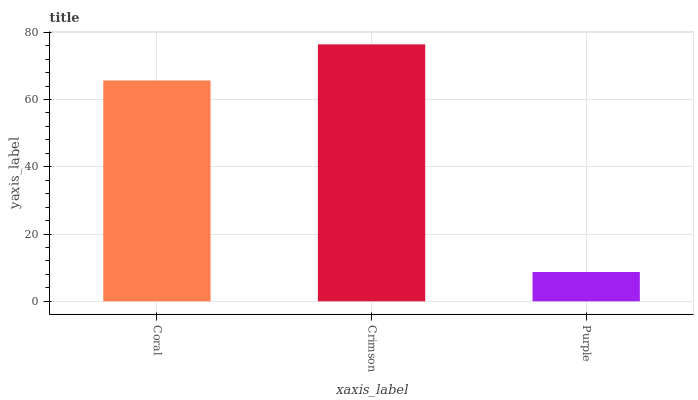Is Crimson the minimum?
Answer yes or no. No. Is Purple the maximum?
Answer yes or no. No. Is Crimson greater than Purple?
Answer yes or no. Yes. Is Purple less than Crimson?
Answer yes or no. Yes. Is Purple greater than Crimson?
Answer yes or no. No. Is Crimson less than Purple?
Answer yes or no. No. Is Coral the high median?
Answer yes or no. Yes. Is Coral the low median?
Answer yes or no. Yes. Is Purple the high median?
Answer yes or no. No. Is Purple the low median?
Answer yes or no. No. 